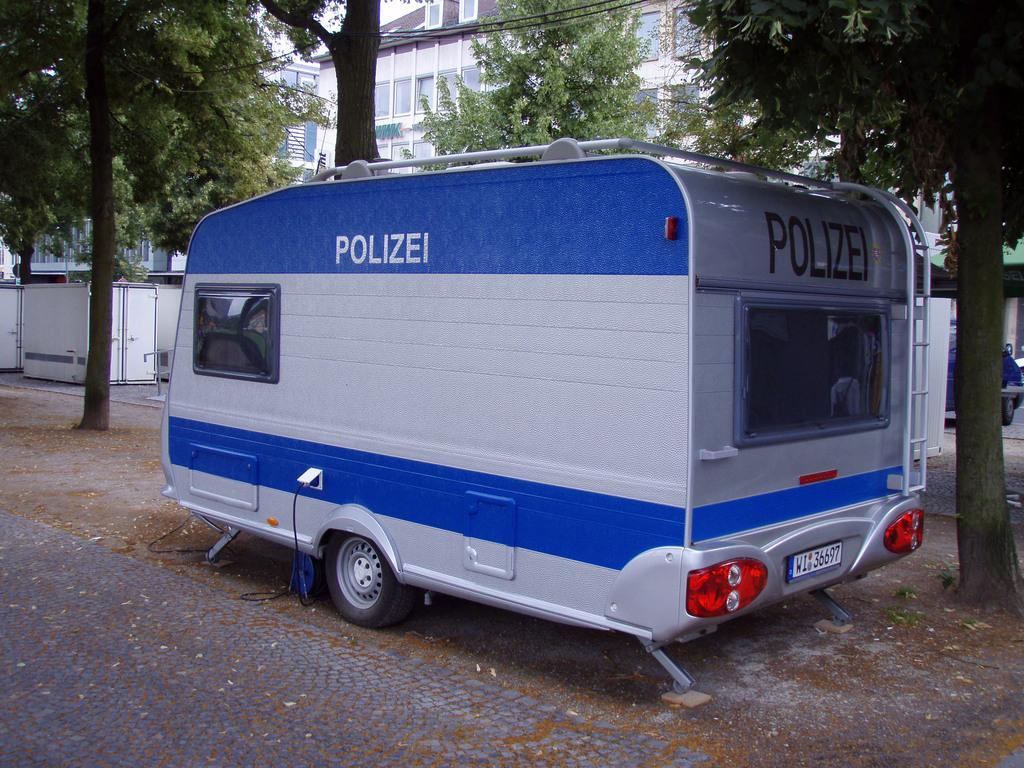Can you describe this image briefly? In this image we can see a vehicle. In the background of the image there are trees, buildings and other objects. At the bottom of the image there is the floor. 